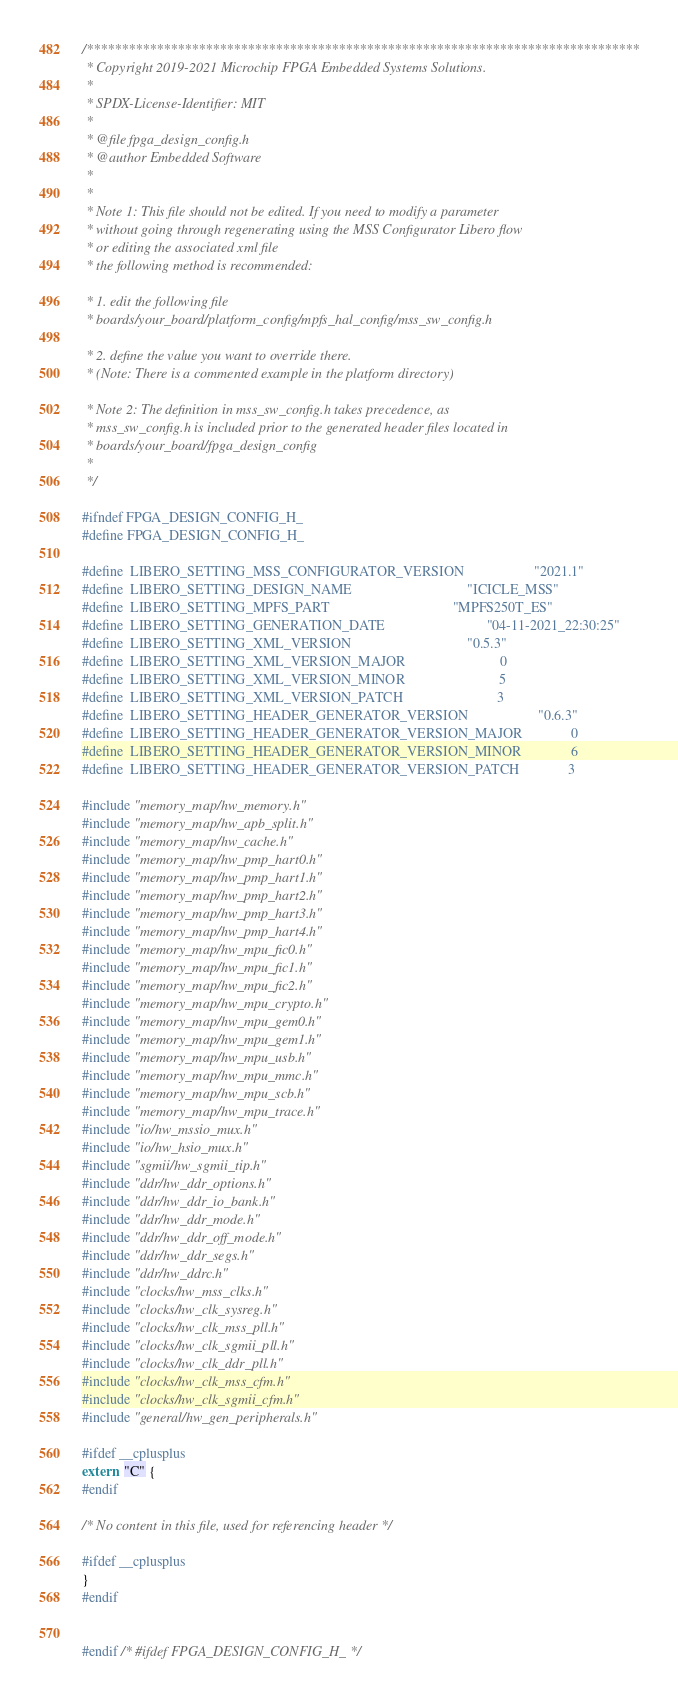Convert code to text. <code><loc_0><loc_0><loc_500><loc_500><_C_>/*******************************************************************************
 * Copyright 2019-2021 Microchip FPGA Embedded Systems Solutions.
 *
 * SPDX-License-Identifier: MIT
 *
 * @file fpga_design_config.h
 * @author Embedded Software
 *
 *
 * Note 1: This file should not be edited. If you need to modify a parameter
 * without going through regenerating using the MSS Configurator Libero flow 
 * or editing the associated xml file
 * the following method is recommended: 

 * 1. edit the following file 
 * boards/your_board/platform_config/mpfs_hal_config/mss_sw_config.h

 * 2. define the value you want to override there.
 * (Note: There is a commented example in the platform directory)

 * Note 2: The definition in mss_sw_config.h takes precedence, as
 * mss_sw_config.h is included prior to the generated header files located in
 * boards/your_board/fpga_design_config
 *
 */

#ifndef FPGA_DESIGN_CONFIG_H_
#define FPGA_DESIGN_CONFIG_H_

#define  LIBERO_SETTING_MSS_CONFIGURATOR_VERSION                    "2021.1"
#define  LIBERO_SETTING_DESIGN_NAME                                 "ICICLE_MSS"
#define  LIBERO_SETTING_MPFS_PART                                   "MPFS250T_ES"
#define  LIBERO_SETTING_GENERATION_DATE                             "04-11-2021_22:30:25"
#define  LIBERO_SETTING_XML_VERSION                                 "0.5.3"
#define  LIBERO_SETTING_XML_VERSION_MAJOR                           0
#define  LIBERO_SETTING_XML_VERSION_MINOR                           5
#define  LIBERO_SETTING_XML_VERSION_PATCH                           3
#define  LIBERO_SETTING_HEADER_GENERATOR_VERSION                    "0.6.3"
#define  LIBERO_SETTING_HEADER_GENERATOR_VERSION_MAJOR              0
#define  LIBERO_SETTING_HEADER_GENERATOR_VERSION_MINOR              6
#define  LIBERO_SETTING_HEADER_GENERATOR_VERSION_PATCH              3

#include "memory_map/hw_memory.h"
#include "memory_map/hw_apb_split.h"
#include "memory_map/hw_cache.h"
#include "memory_map/hw_pmp_hart0.h"
#include "memory_map/hw_pmp_hart1.h"
#include "memory_map/hw_pmp_hart2.h"
#include "memory_map/hw_pmp_hart3.h"
#include "memory_map/hw_pmp_hart4.h"
#include "memory_map/hw_mpu_fic0.h"
#include "memory_map/hw_mpu_fic1.h"
#include "memory_map/hw_mpu_fic2.h"
#include "memory_map/hw_mpu_crypto.h"
#include "memory_map/hw_mpu_gem0.h"
#include "memory_map/hw_mpu_gem1.h"
#include "memory_map/hw_mpu_usb.h"
#include "memory_map/hw_mpu_mmc.h"
#include "memory_map/hw_mpu_scb.h"
#include "memory_map/hw_mpu_trace.h"
#include "io/hw_mssio_mux.h"
#include "io/hw_hsio_mux.h"
#include "sgmii/hw_sgmii_tip.h"
#include "ddr/hw_ddr_options.h"
#include "ddr/hw_ddr_io_bank.h"
#include "ddr/hw_ddr_mode.h"
#include "ddr/hw_ddr_off_mode.h"
#include "ddr/hw_ddr_segs.h"
#include "ddr/hw_ddrc.h"
#include "clocks/hw_mss_clks.h"
#include "clocks/hw_clk_sysreg.h"
#include "clocks/hw_clk_mss_pll.h"
#include "clocks/hw_clk_sgmii_pll.h"
#include "clocks/hw_clk_ddr_pll.h"
#include "clocks/hw_clk_mss_cfm.h"
#include "clocks/hw_clk_sgmii_cfm.h"
#include "general/hw_gen_peripherals.h"

#ifdef __cplusplus
extern  "C" {
#endif

/* No content in this file, used for referencing header */

#ifdef __cplusplus
}
#endif


#endif /* #ifdef FPGA_DESIGN_CONFIG_H_ */

</code> 